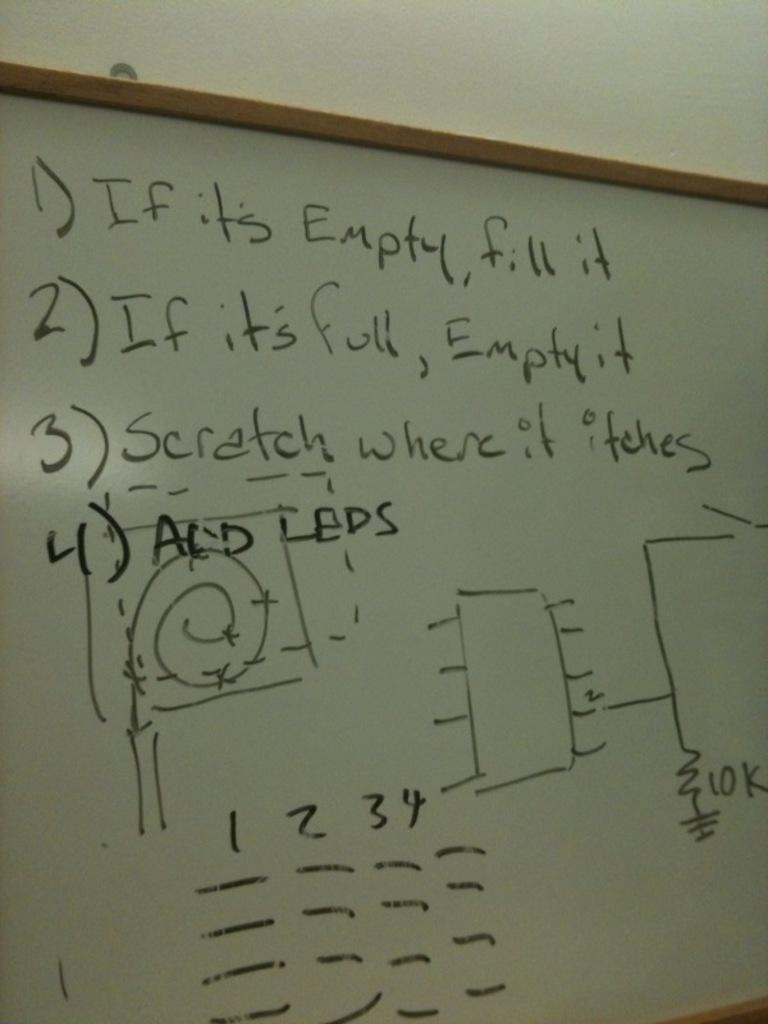Provide a one-sentence caption for the provided image. A white board says if it is empty, fill it. 